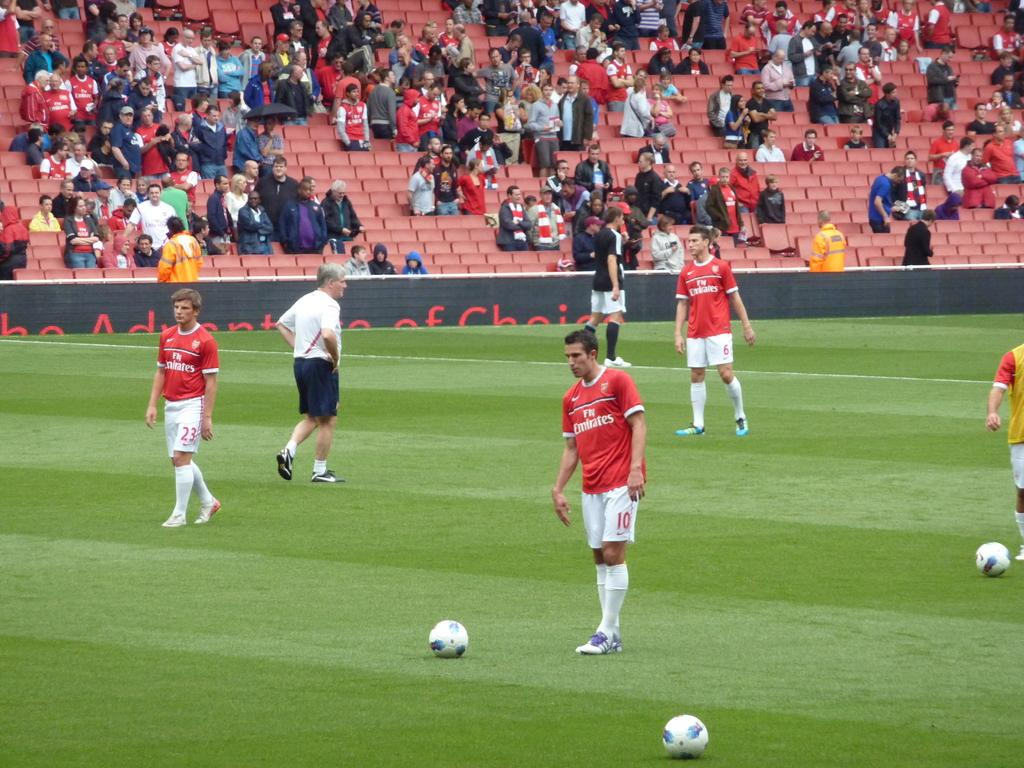<image>
Summarize the visual content of the image. A soccer stadium filled with spectators watching a match for the Emirates. 